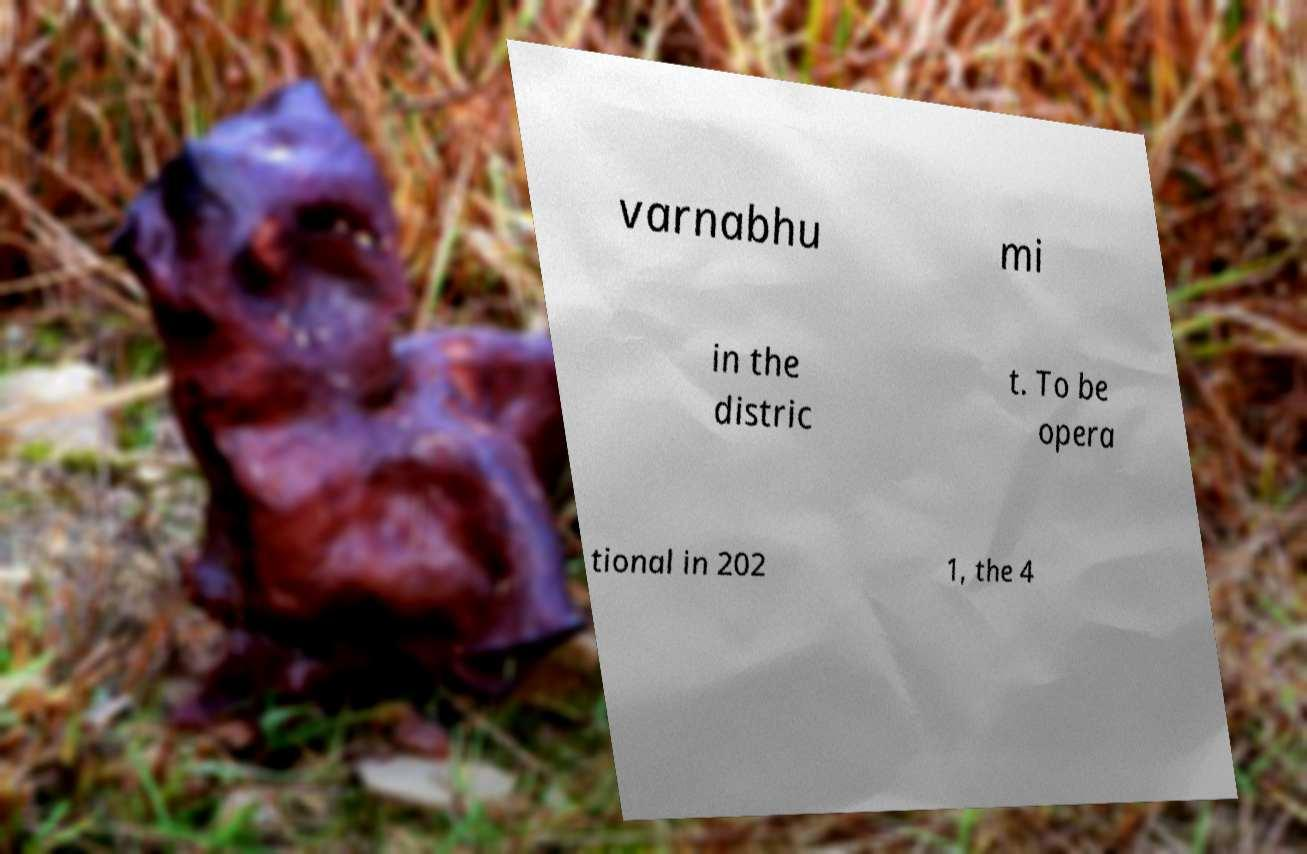Can you accurately transcribe the text from the provided image for me? varnabhu mi in the distric t. To be opera tional in 202 1, the 4 